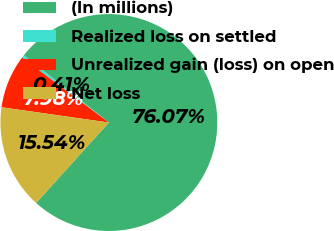<chart> <loc_0><loc_0><loc_500><loc_500><pie_chart><fcel>(In millions)<fcel>Realized loss on settled<fcel>Unrealized gain (loss) on open<fcel>Net loss<nl><fcel>76.06%<fcel>0.41%<fcel>7.98%<fcel>15.54%<nl></chart> 